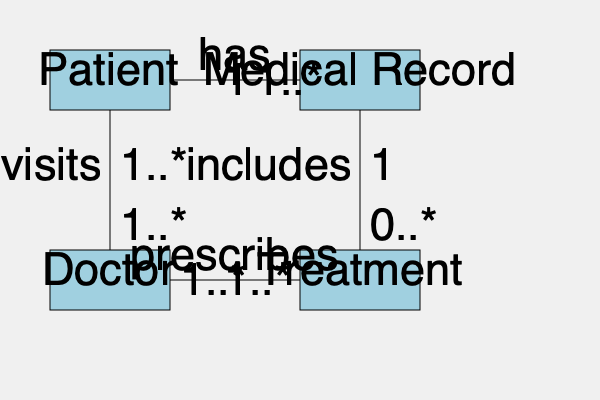Based on the entity-relationship diagram for a healthcare database system, which relationship between entities ensures that every medical record is associated with exactly one patient, while a patient can have multiple medical records? To answer this question, let's analyze the entity-relationship diagram step by step:

1. Identify the entities involved:
   - Patient
   - Medical Record
   - Doctor
   - Treatment

2. Focus on the relationship between Patient and Medical Record:
   - There is a direct line connecting these two entities.
   - The relationship is labeled "has".

3. Examine the cardinality of this relationship:
   - On the Patient side, we see "1".
   - On the Medical Record side, we see "1..*".

4. Interpret the cardinality:
   - "1" on the Patient side means that each medical record is associated with exactly one patient.
   - "1..*" on the Medical Record side means that a patient can have one or many medical records.

5. Verify that this matches the question requirements:
   - Every medical record is associated with exactly one patient: ✓
   - A patient can have multiple medical records: ✓

6. Check other relationships to ensure they don't contradict this interpretation:
   - Patient-Doctor relationship: "1..*" on both sides (many-to-many), doesn't affect our answer.
   - Doctor-Treatment relationship: "1..*" on both sides (many-to-many), doesn't affect our answer.
   - Medical Record-Treatment relationship: "1" to "0..*", supports our interpretation that a medical record can include multiple treatments.

Therefore, the relationship between Patient and Medical Record, labeled "has", is the one that satisfies the conditions stated in the question.
Answer: The "has" relationship between Patient and Medical Record 